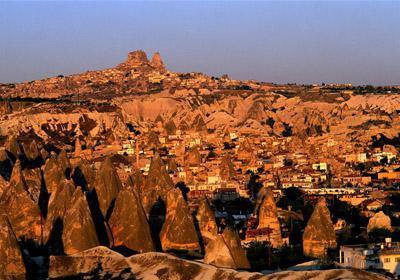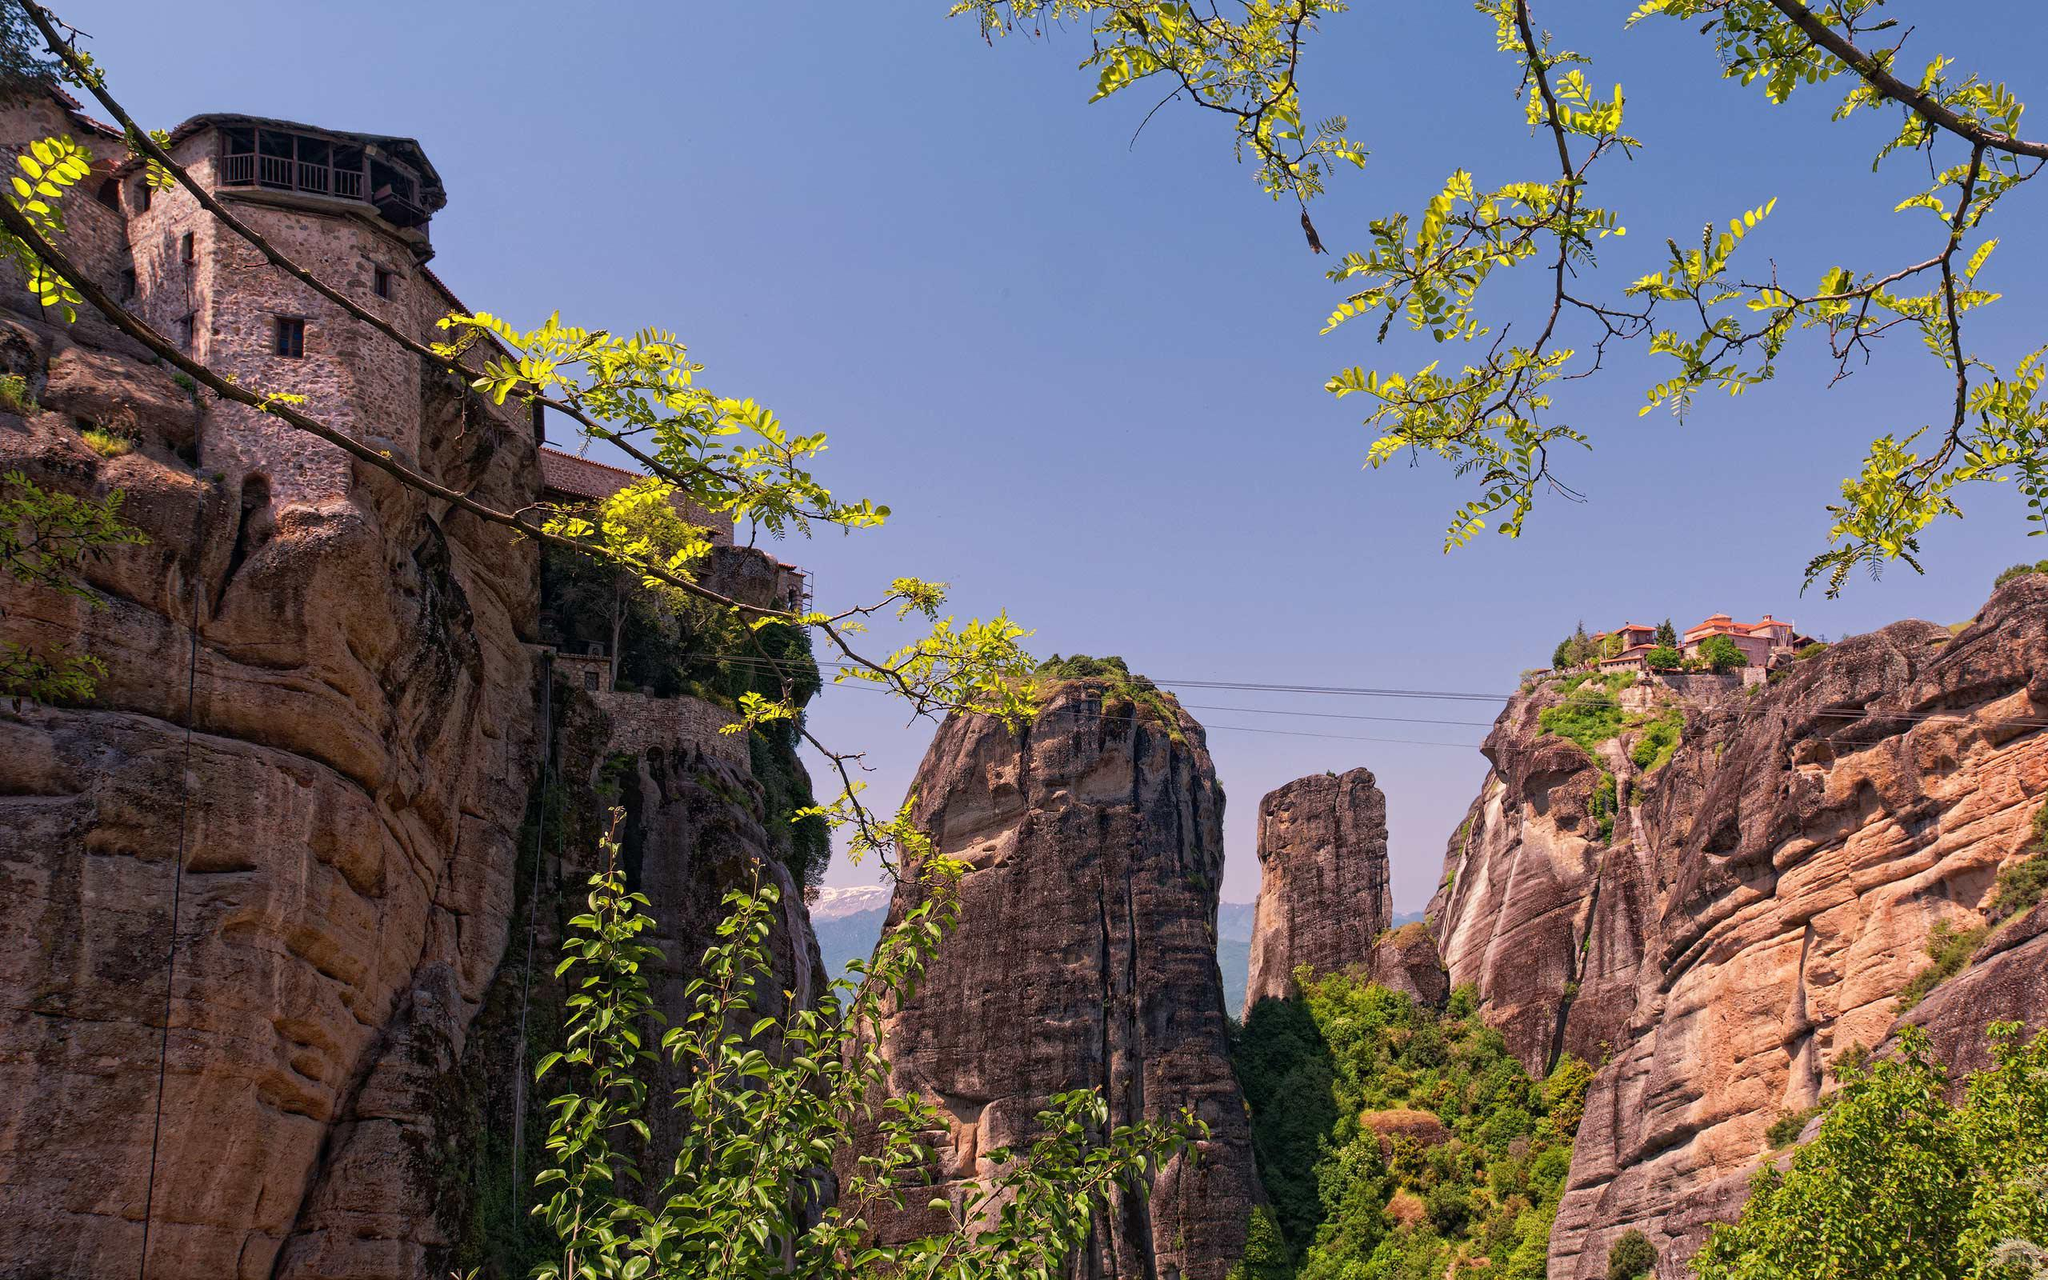The first image is the image on the left, the second image is the image on the right. For the images shown, is this caption "There are more than three  buildings in the right image, and mountains in the left image." true? Answer yes or no. No. The first image is the image on the left, the second image is the image on the right. Considering the images on both sides, is "In at least one image there is a single large cloud over at least seven triangle rock structures." valid? Answer yes or no. No. 